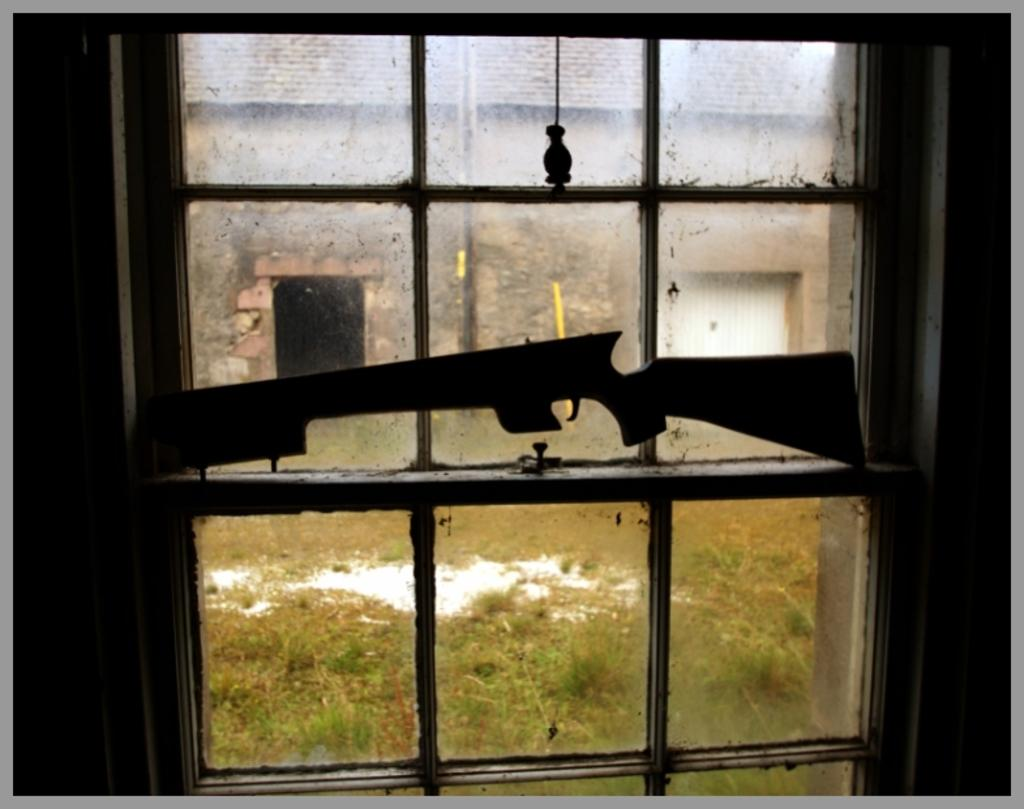What type of image is being shown? The image is an edited picture. What can be seen on the window in the image? There is a gun on the window. What is visible behind the window? There is a building behind the window. What type of vegetation is at the bottom of the image? There is grass at the bottom of the image. How does the visitor help the person in the image gain knowledge? There is no visitor present in the image, so it is not possible to determine how they might help someone gain knowledge. 